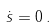<formula> <loc_0><loc_0><loc_500><loc_500>\dot { s } = 0 \, .</formula> 